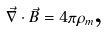Convert formula to latex. <formula><loc_0><loc_0><loc_500><loc_500>\vec { \nabla } \cdot \vec { B } = 4 \pi \rho _ { m } \text {,}</formula> 